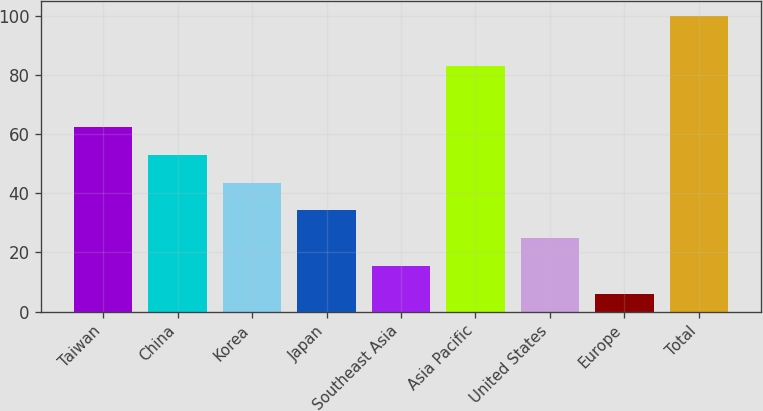Convert chart to OTSL. <chart><loc_0><loc_0><loc_500><loc_500><bar_chart><fcel>Taiwan<fcel>China<fcel>Korea<fcel>Japan<fcel>Southeast Asia<fcel>Asia Pacific<fcel>United States<fcel>Europe<fcel>Total<nl><fcel>62.4<fcel>53<fcel>43.6<fcel>34.2<fcel>15.4<fcel>83<fcel>24.8<fcel>6<fcel>100<nl></chart> 